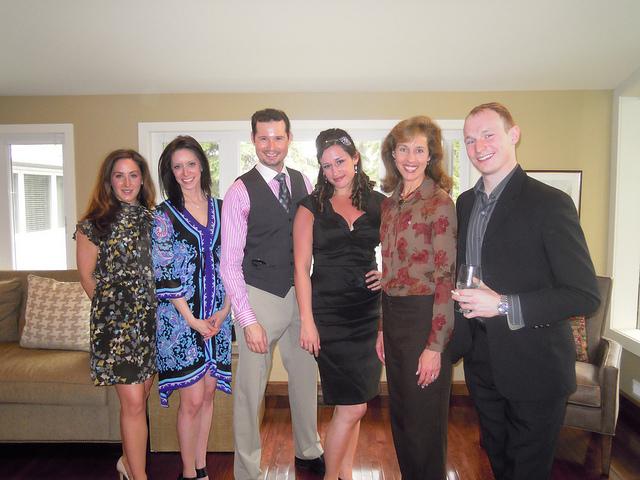Is the woman on the right wearing a long gown?
Short answer required. No. Is it likely these women adhere to the Muslim faith?
Quick response, please. No. What type of pants are the majority of the woman wearing?
Give a very brief answer. None. How many skateboards are there?
Concise answer only. 0. Is anyone wearing a watch?
Concise answer only. Yes. What color is the dress on the second woman from the left?
Keep it brief. Blue. 